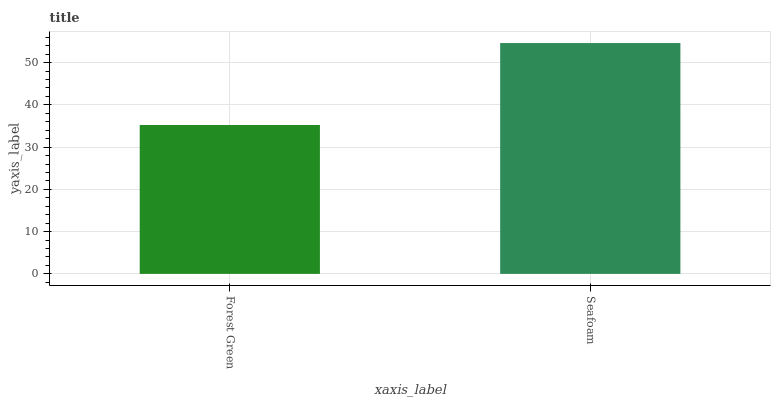Is Forest Green the minimum?
Answer yes or no. Yes. Is Seafoam the maximum?
Answer yes or no. Yes. Is Seafoam the minimum?
Answer yes or no. No. Is Seafoam greater than Forest Green?
Answer yes or no. Yes. Is Forest Green less than Seafoam?
Answer yes or no. Yes. Is Forest Green greater than Seafoam?
Answer yes or no. No. Is Seafoam less than Forest Green?
Answer yes or no. No. Is Seafoam the high median?
Answer yes or no. Yes. Is Forest Green the low median?
Answer yes or no. Yes. Is Forest Green the high median?
Answer yes or no. No. Is Seafoam the low median?
Answer yes or no. No. 